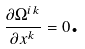<formula> <loc_0><loc_0><loc_500><loc_500>\frac { \partial \Omega ^ { i k } } { \partial x ^ { k } } = 0 \text {.}</formula> 